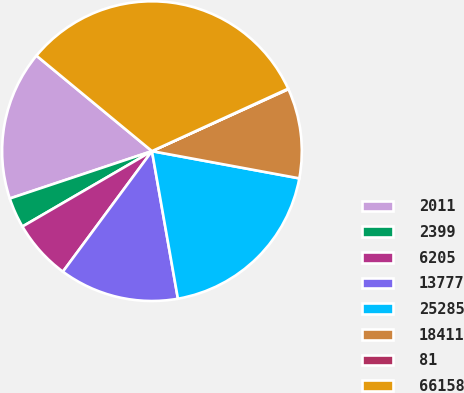Convert chart. <chart><loc_0><loc_0><loc_500><loc_500><pie_chart><fcel>2011<fcel>2399<fcel>6205<fcel>13777<fcel>25285<fcel>18411<fcel>81<fcel>66158<nl><fcel>16.11%<fcel>3.27%<fcel>6.48%<fcel>12.9%<fcel>19.32%<fcel>9.69%<fcel>0.06%<fcel>32.16%<nl></chart> 